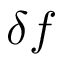Convert formula to latex. <formula><loc_0><loc_0><loc_500><loc_500>\delta f</formula> 